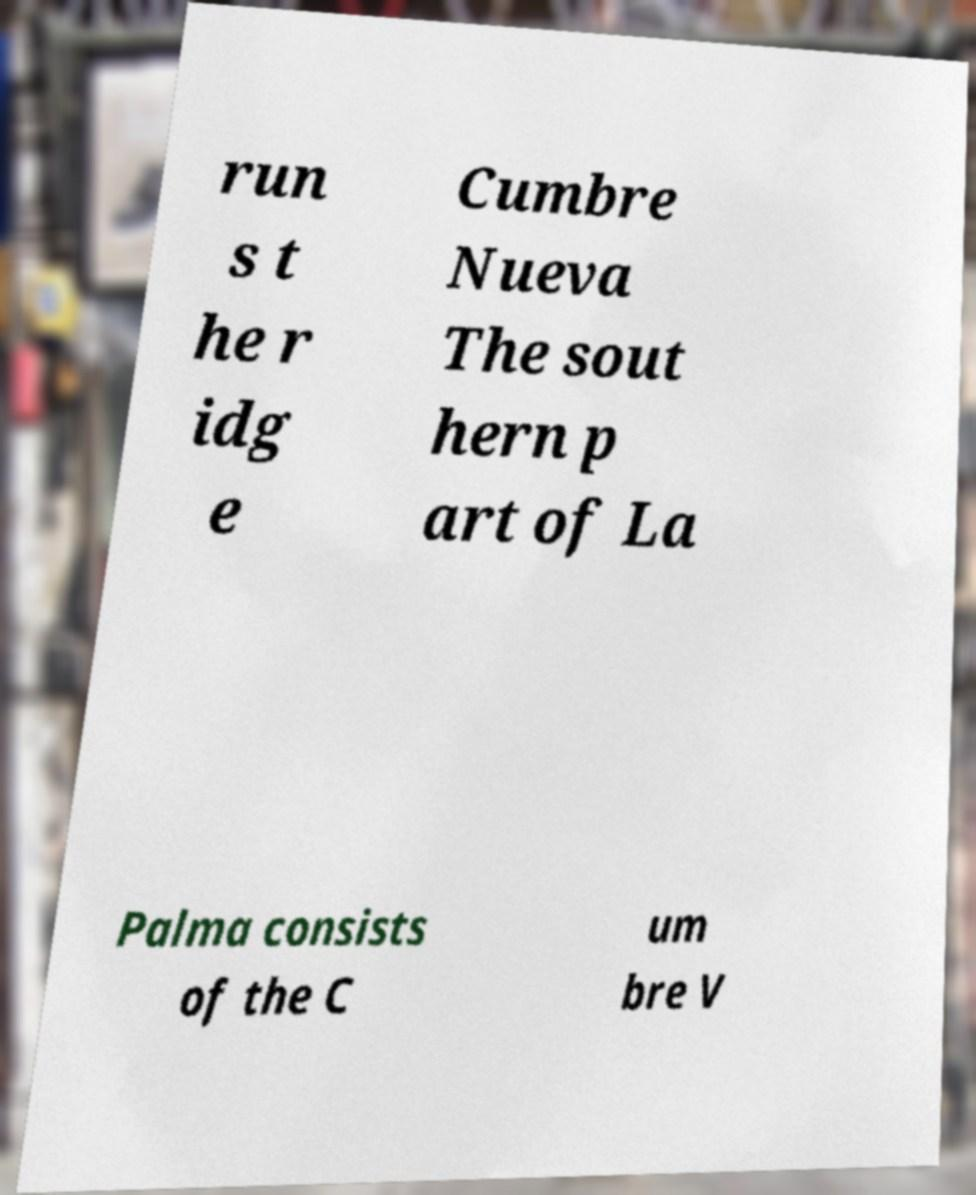For documentation purposes, I need the text within this image transcribed. Could you provide that? run s t he r idg e Cumbre Nueva The sout hern p art of La Palma consists of the C um bre V 